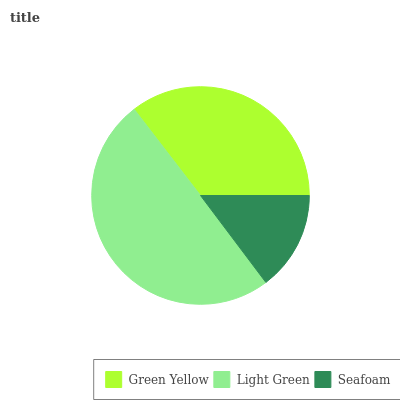Is Seafoam the minimum?
Answer yes or no. Yes. Is Light Green the maximum?
Answer yes or no. Yes. Is Light Green the minimum?
Answer yes or no. No. Is Seafoam the maximum?
Answer yes or no. No. Is Light Green greater than Seafoam?
Answer yes or no. Yes. Is Seafoam less than Light Green?
Answer yes or no. Yes. Is Seafoam greater than Light Green?
Answer yes or no. No. Is Light Green less than Seafoam?
Answer yes or no. No. Is Green Yellow the high median?
Answer yes or no. Yes. Is Green Yellow the low median?
Answer yes or no. Yes. Is Light Green the high median?
Answer yes or no. No. Is Light Green the low median?
Answer yes or no. No. 